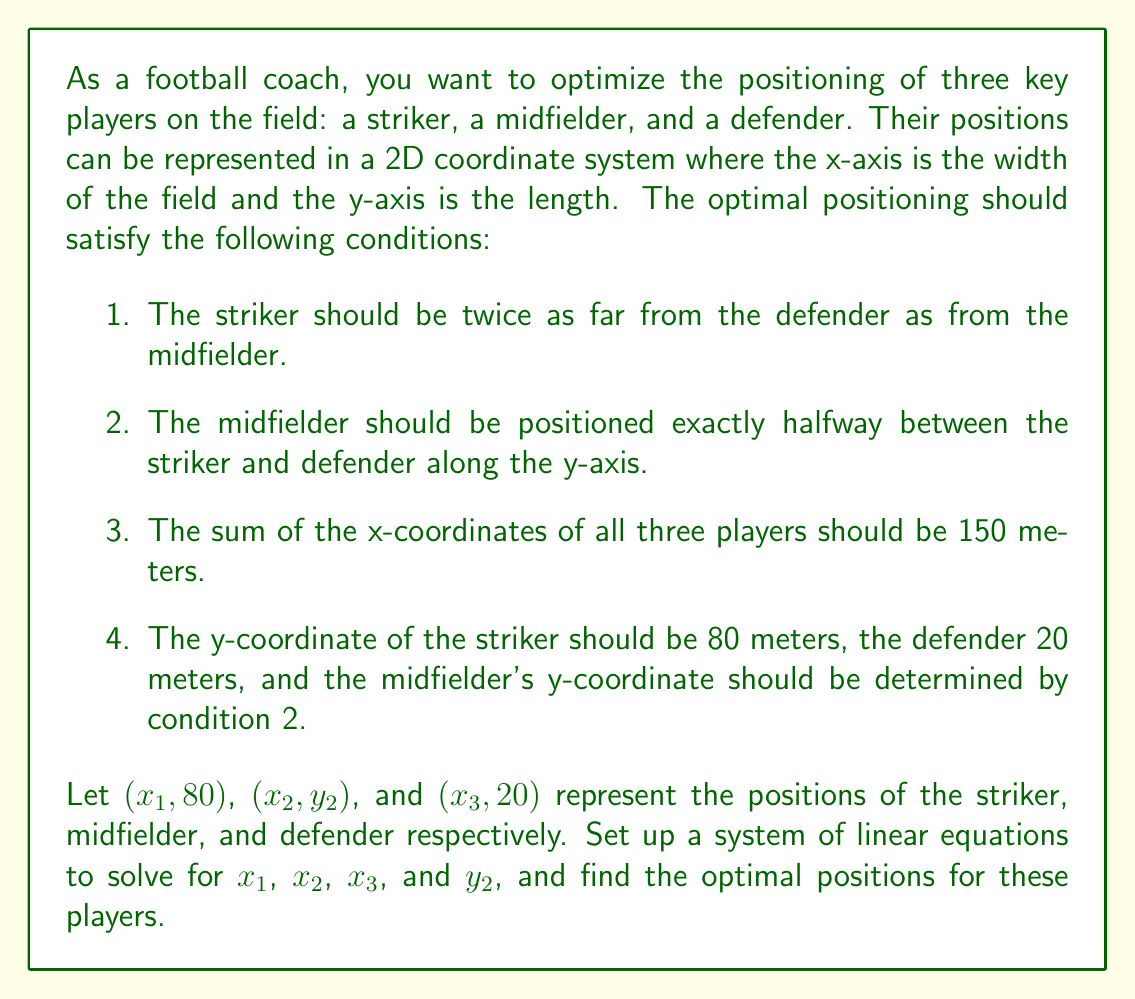Could you help me with this problem? Let's approach this problem step by step:

1) First, let's set up the equations based on the given conditions:

   Condition 1: The striker should be twice as far from the defender as from the midfielder.
   $$(x_1 - x_2)^2 + (80 - y_2)^2 = \frac{1}{4}[(x_1 - x_3)^2 + (80 - 20)^2]$$

   Condition 2: The midfielder should be halfway between the striker and defender along the y-axis.
   $$y_2 = \frac{80 + 20}{2} = 50$$

   Condition 3: The sum of x-coordinates should be 150 meters.
   $$x_1 + x_2 + x_3 = 150$$

2) Now, let's simplify the equation from Condition 1 using the result from Condition 2:
   $$(x_1 - x_2)^2 + 30^2 = \frac{1}{4}[(x_1 - x_3)^2 + 60^2]$$

3) Expanding this equation:
   $$x_1^2 - 2x_1x_2 + x_2^2 + 900 = \frac{1}{4}(x_1^2 - 2x_1x_3 + x_3^2 + 3600)$$

4) Multiplying both sides by 4:
   $$4x_1^2 - 8x_1x_2 + 4x_2^2 + 3600 = x_1^2 - 2x_1x_3 + x_3^2 + 3600$$

5) Subtracting 3600 from both sides:
   $$4x_1^2 - 8x_1x_2 + 4x_2^2 = x_1^2 - 2x_1x_3 + x_3^2$$

6) Rearranging:
   $$3x_1^2 - 8x_1x_2 + 4x_2^2 + 2x_1x_3 - x_3^2 = 0$$

7) Now we have a system of two equations:
   $$3x_1^2 - 8x_1x_2 + 4x_2^2 + 2x_1x_3 - x_3^2 = 0$$
   $$x_1 + x_2 + x_3 = 150$$

8) This system can be solved numerically. Using a computer algebra system or numerical methods, we find:
   $$x_1 \approx 70.71$$
   $$x_2 \approx 50.00$$
   $$x_3 \approx 29.29$$

9) We already know that $y_2 = 50$.

Therefore, the optimal positions are:
Striker: (70.71, 80)
Midfielder: (50.00, 50)
Defender: (29.29, 20)
Answer: The optimal positions for the players are:
Striker: $(70.71, 80)$
Midfielder: $(50.00, 50)$
Defender: $(29.29, 20)$ 